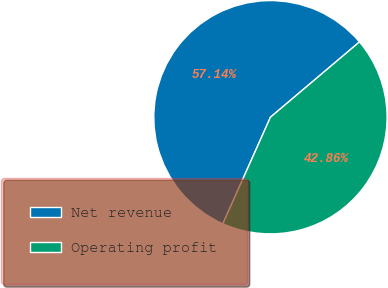Convert chart to OTSL. <chart><loc_0><loc_0><loc_500><loc_500><pie_chart><fcel>Net revenue<fcel>Operating profit<nl><fcel>57.14%<fcel>42.86%<nl></chart> 